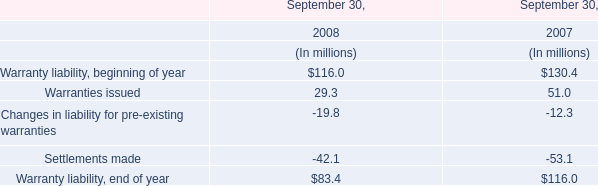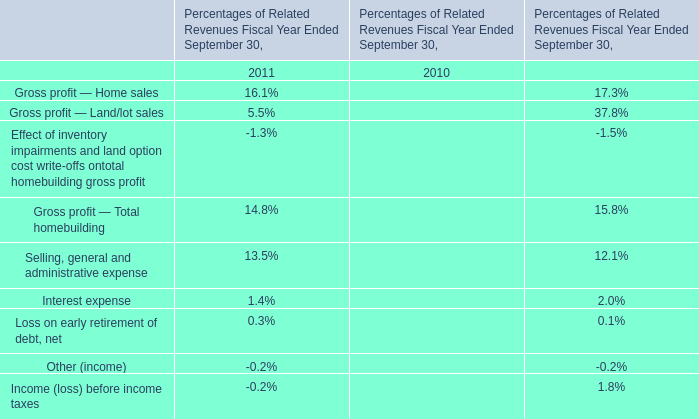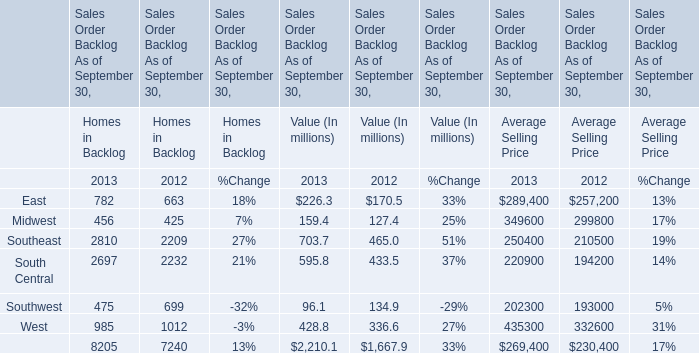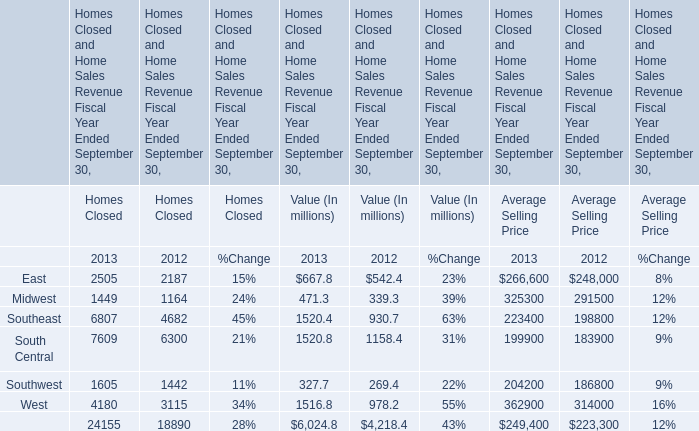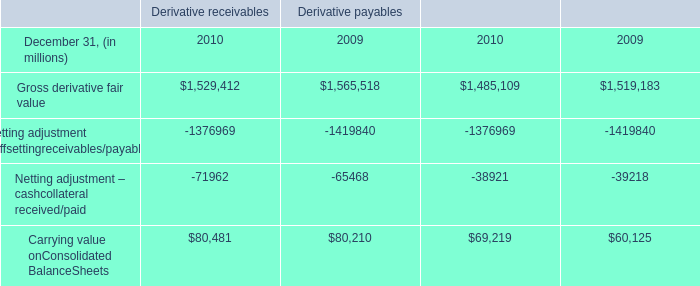Which year is East for Homes in Backlog the highest? 
Answer: 2013. 